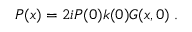<formula> <loc_0><loc_0><loc_500><loc_500>P ( x ) = 2 i P ( 0 ) k ( 0 ) G ( x , 0 ) \, .</formula> 